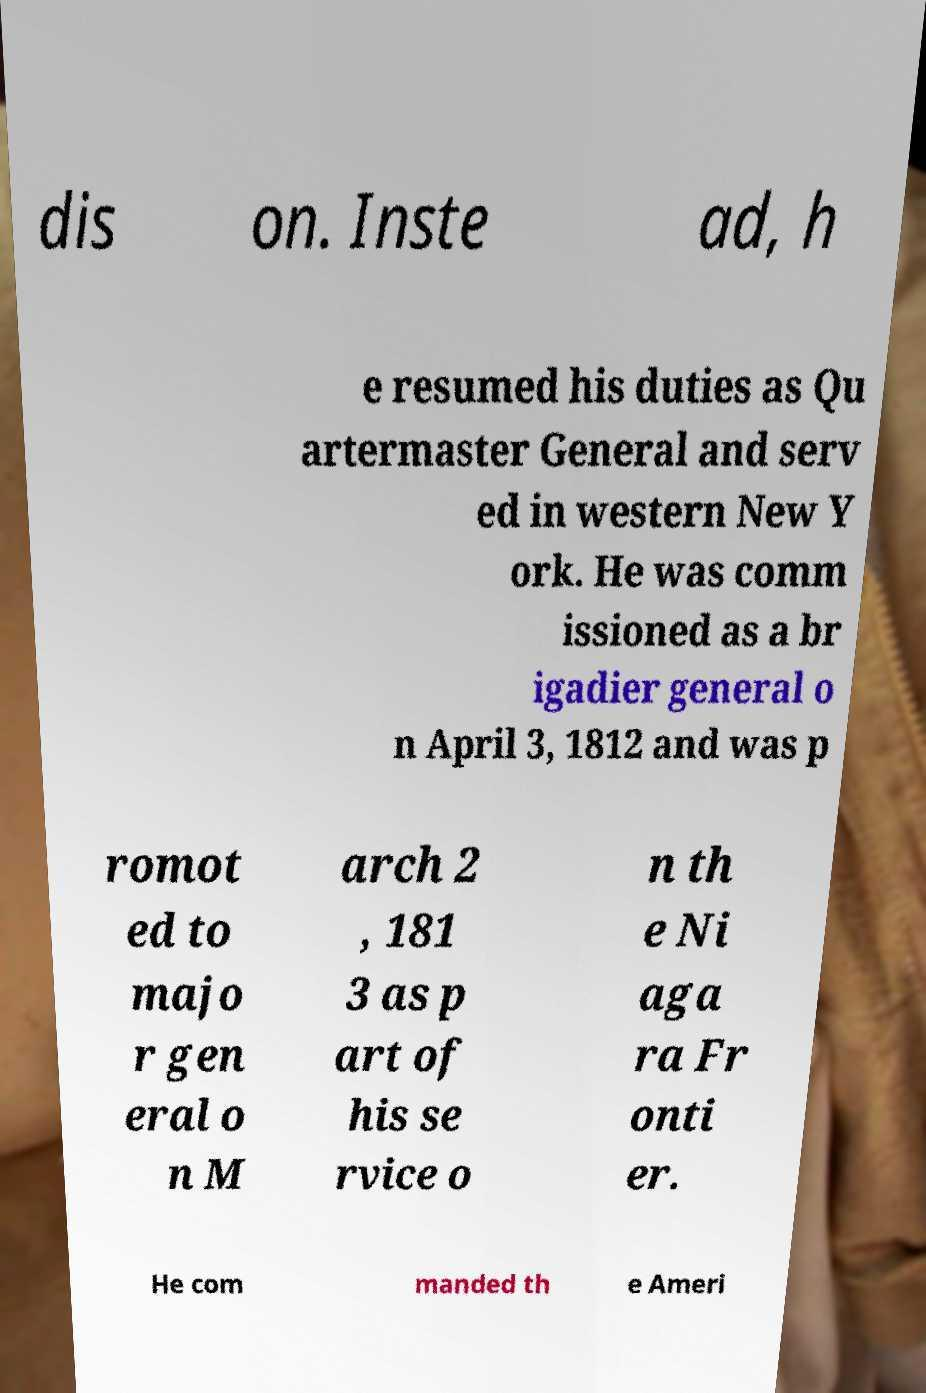Can you read and provide the text displayed in the image?This photo seems to have some interesting text. Can you extract and type it out for me? dis on. Inste ad, h e resumed his duties as Qu artermaster General and serv ed in western New Y ork. He was comm issioned as a br igadier general o n April 3, 1812 and was p romot ed to majo r gen eral o n M arch 2 , 181 3 as p art of his se rvice o n th e Ni aga ra Fr onti er. He com manded th e Ameri 